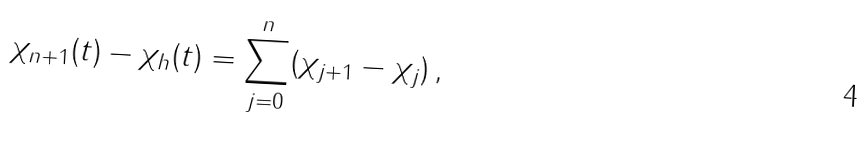<formula> <loc_0><loc_0><loc_500><loc_500>\chi _ { n + 1 } ( t ) - \chi _ { h } ( t ) = \sum _ { j = 0 } ^ { n } ( \chi _ { j + 1 } - \chi _ { j } ) \, ,</formula> 